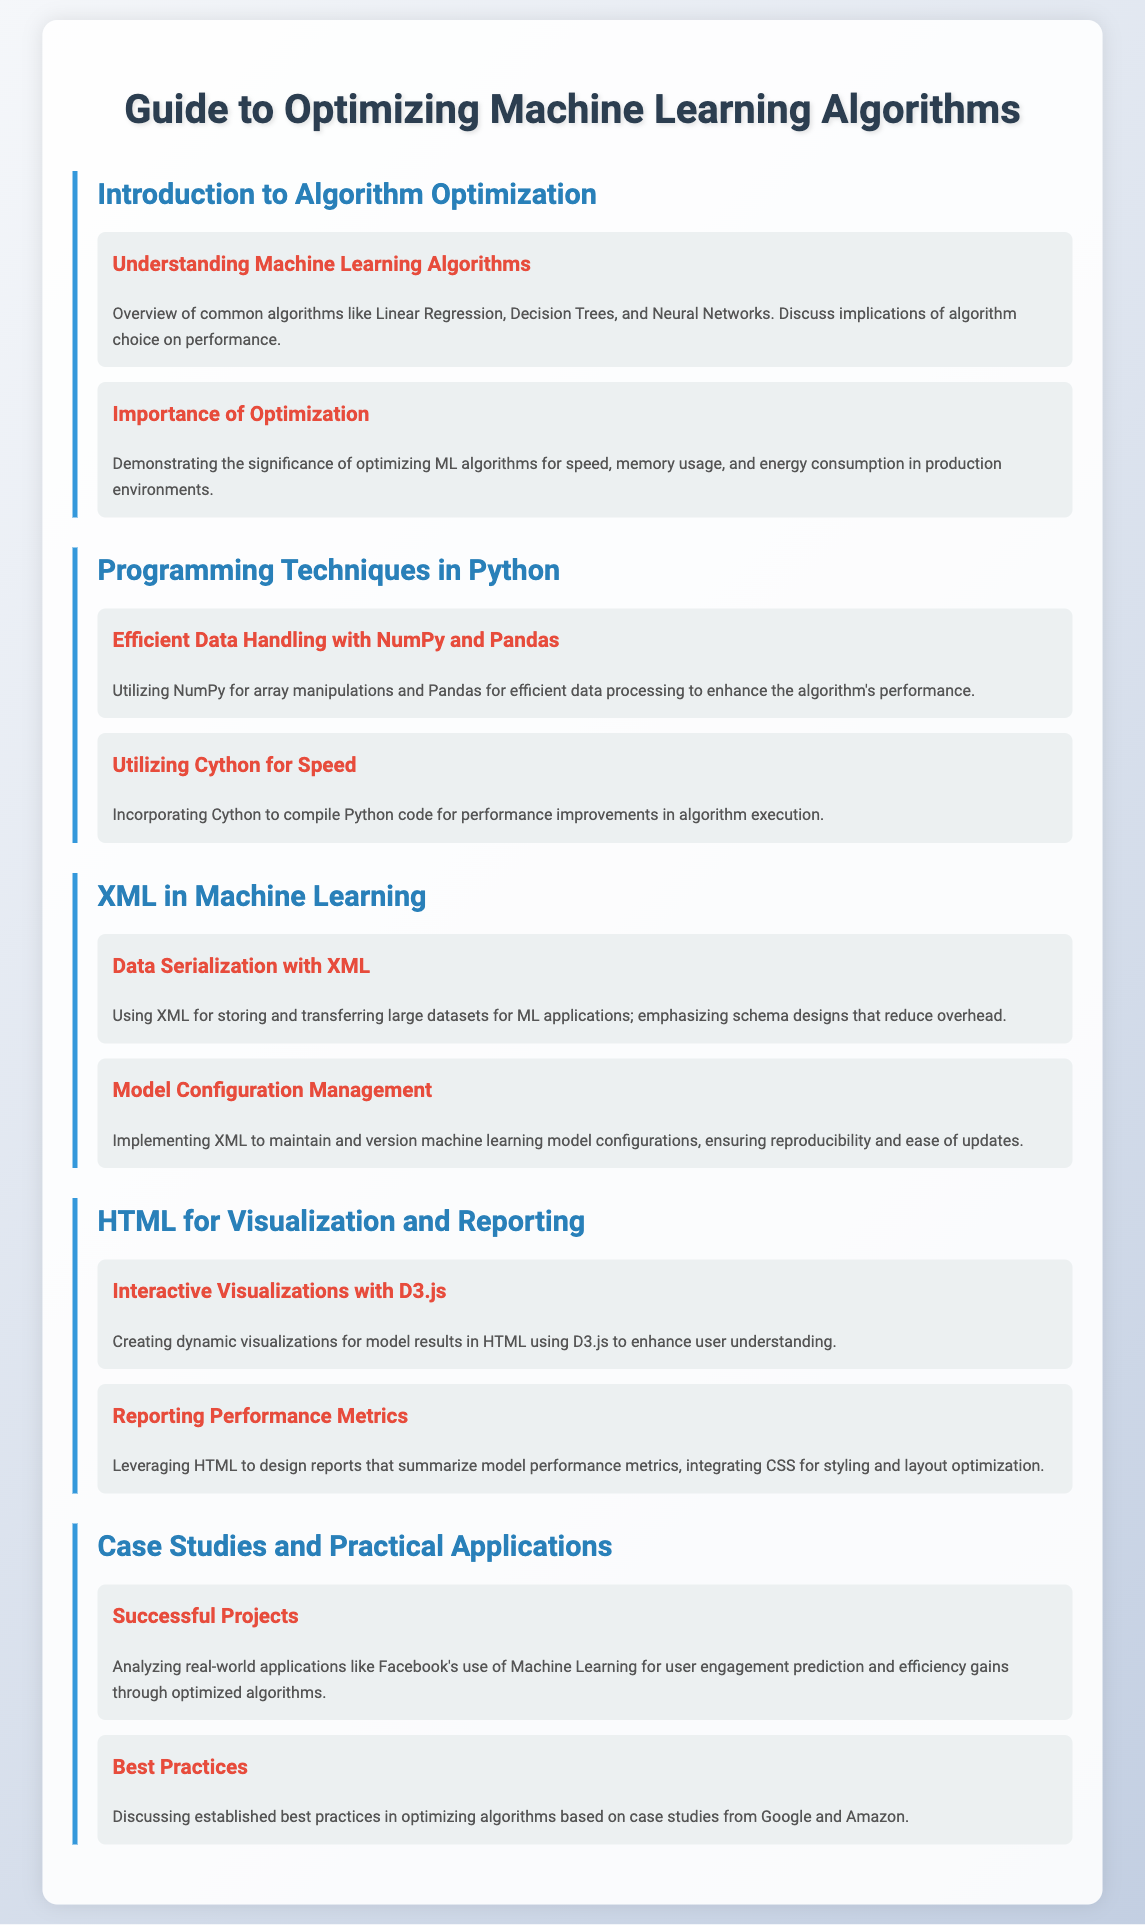What is the title of the document? The title is mentioned prominently at the top of the document.
Answer: Guide to Optimizing Machine Learning Algorithms What are common algorithms discussed? The document lists common algorithms in the introduction section.
Answer: Linear Regression, Decision Trees, Neural Networks What programming technique is highlighted for data handling? The document specifies techniques under the Python programming section, emphasizing efficient data handling.
Answer: NumPy and Pandas What method is suggested for speed improvement? The document recommends a specific method to enhance performance under the Python programming techniques section.
Answer: Cython What is the focus of XML in machine learning mentioned? The document describes the applications of XML in terms of data management.
Answer: Data Serialization What visualization library is mentioned for HTML? The document points out the use of a specific library for creating visualizations in the HTML section.
Answer: D3.js Which company’s application of machine learning is highlighted? A real-world application providing insight into the practical use of machine learning is mentioned in the case studies section.
Answer: Facebook What is one established best practice discussed? The document addresses industry standards in algorithm optimization based on renowned companies.
Answer: Best Practices 